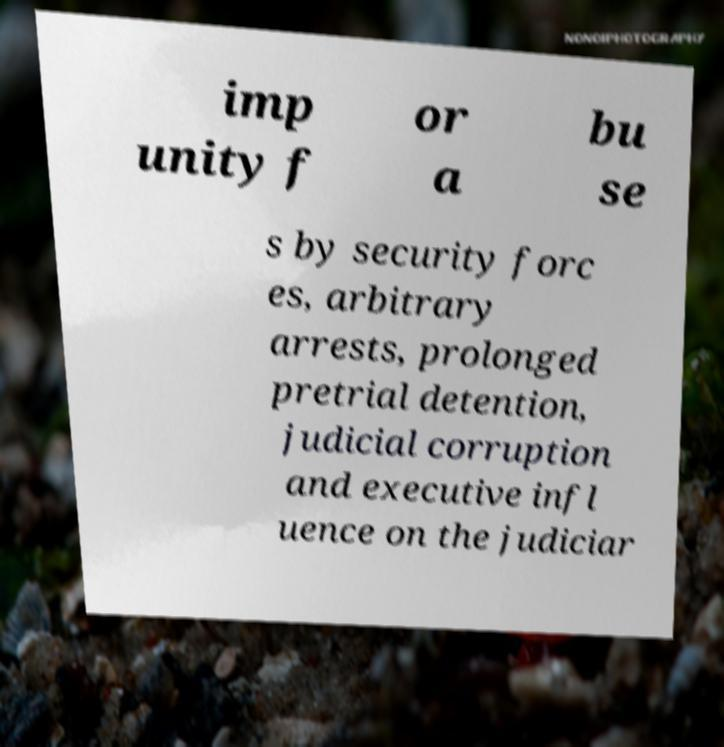Could you extract and type out the text from this image? imp unity f or a bu se s by security forc es, arbitrary arrests, prolonged pretrial detention, judicial corruption and executive infl uence on the judiciar 